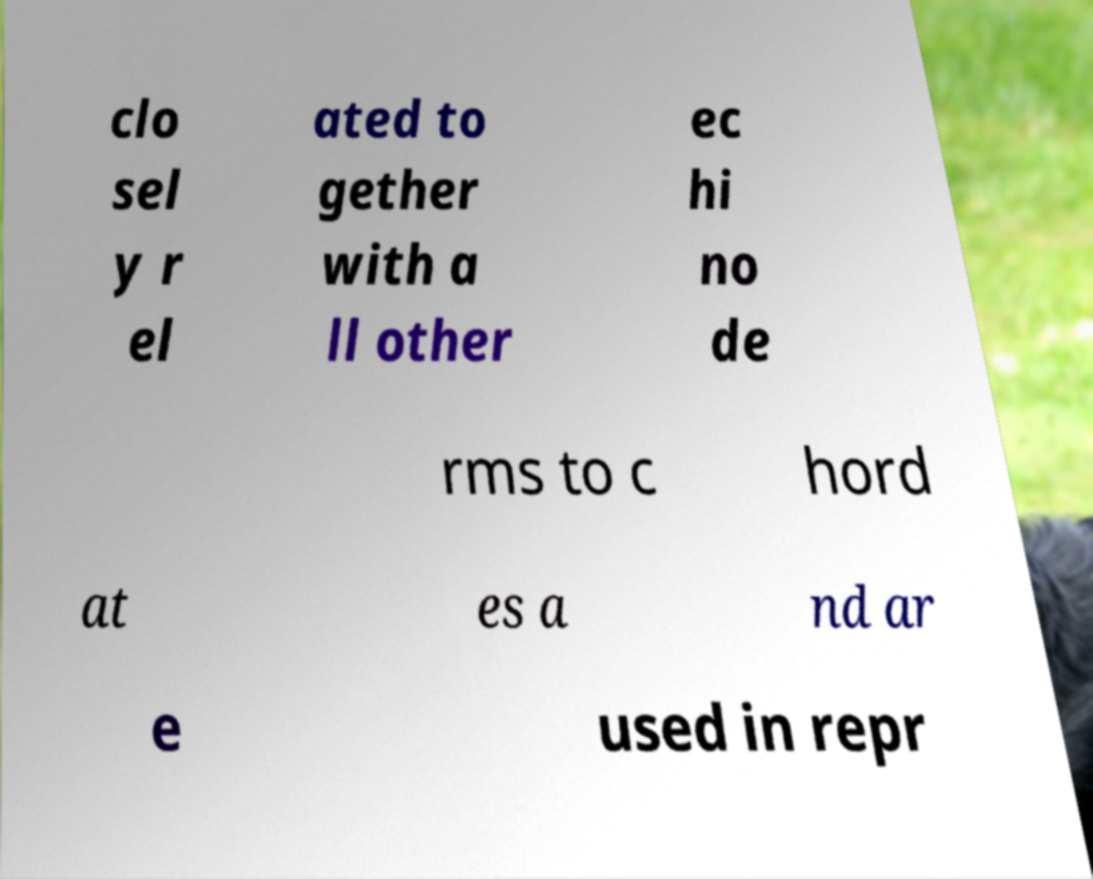Could you assist in decoding the text presented in this image and type it out clearly? clo sel y r el ated to gether with a ll other ec hi no de rms to c hord at es a nd ar e used in repr 